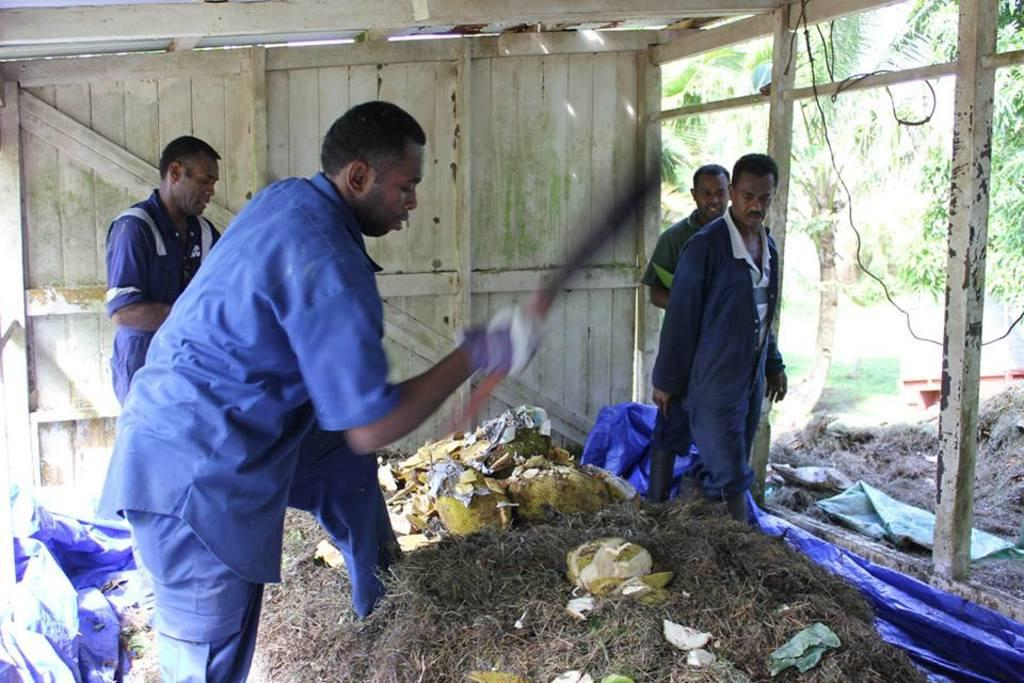What are the people in the image standing on? The people in the image are standing on the grass. What can be found on the grass besides the people? There is a peel of a fruit on the grass. Where is the door located in the image? The door is at the back side of the image. What type of vegetation is on the right side of the image? There are trees at the right side of the image. What type of hospital is visible in the image? There is no hospital present in the image. Who is the owner of the fruit peel in the image? There is no indication of ownership in the image, and the fruit peel is not associated with any person or object. 